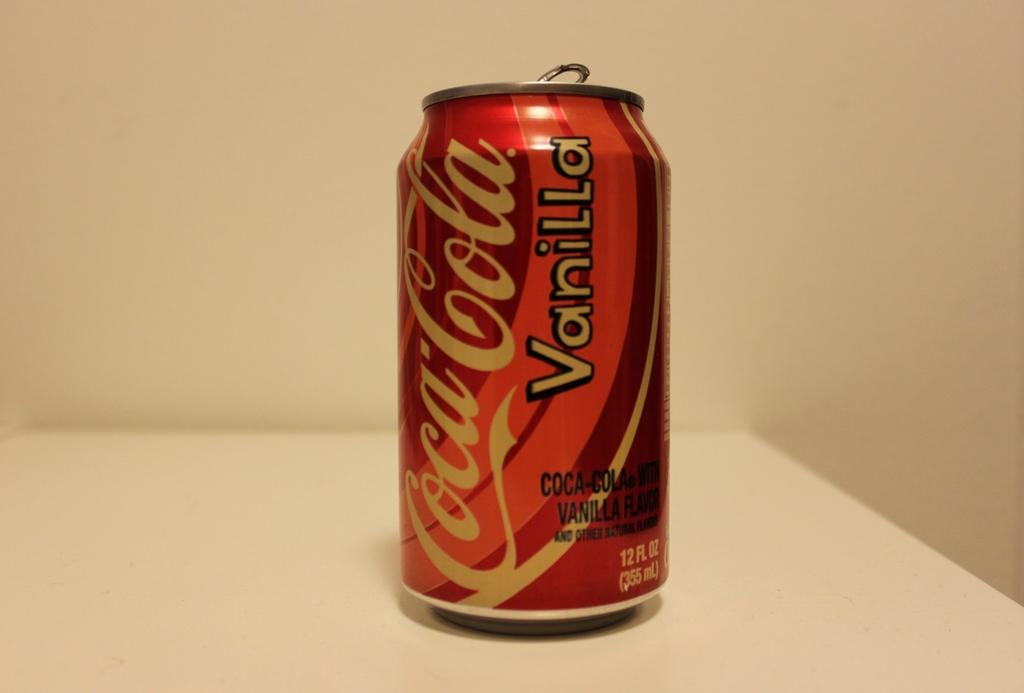<image>
Write a terse but informative summary of the picture. A can of Coca-Cola says that it is vanilla flavored 